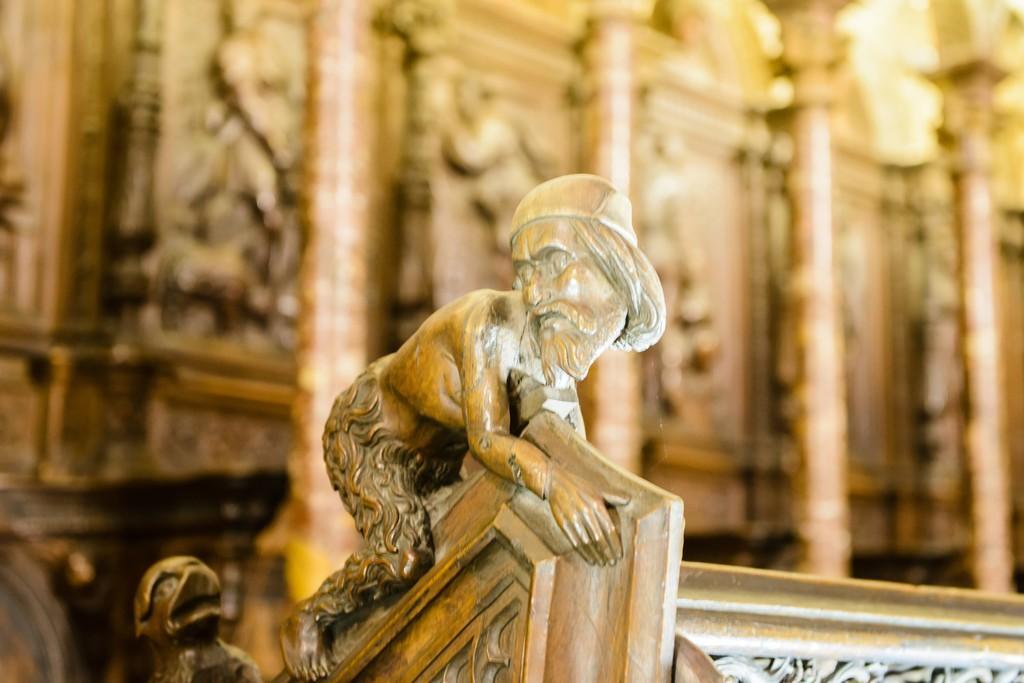Please provide a concise description of this image. In this image, we can see a wooden carved sculpture, in the background, we can see some wooden carved designs. 